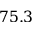<formula> <loc_0><loc_0><loc_500><loc_500>7 5 . 3</formula> 